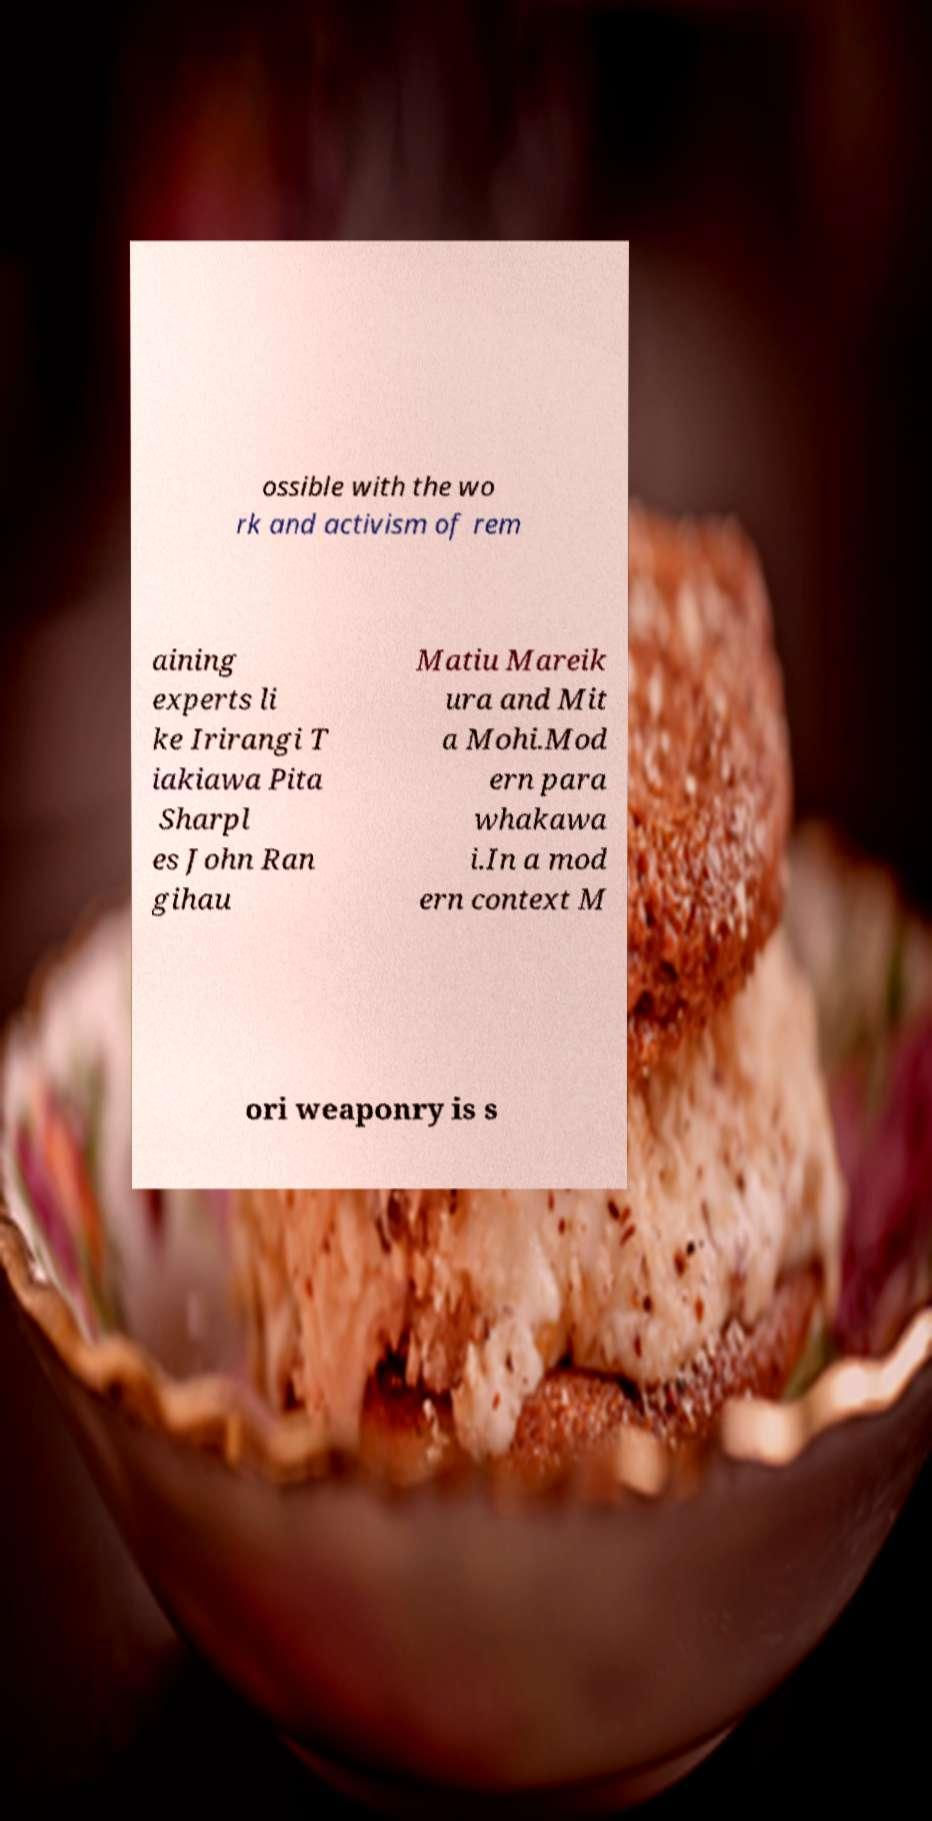Can you accurately transcribe the text from the provided image for me? ossible with the wo rk and activism of rem aining experts li ke Irirangi T iakiawa Pita Sharpl es John Ran gihau Matiu Mareik ura and Mit a Mohi.Mod ern para whakawa i.In a mod ern context M ori weaponry is s 